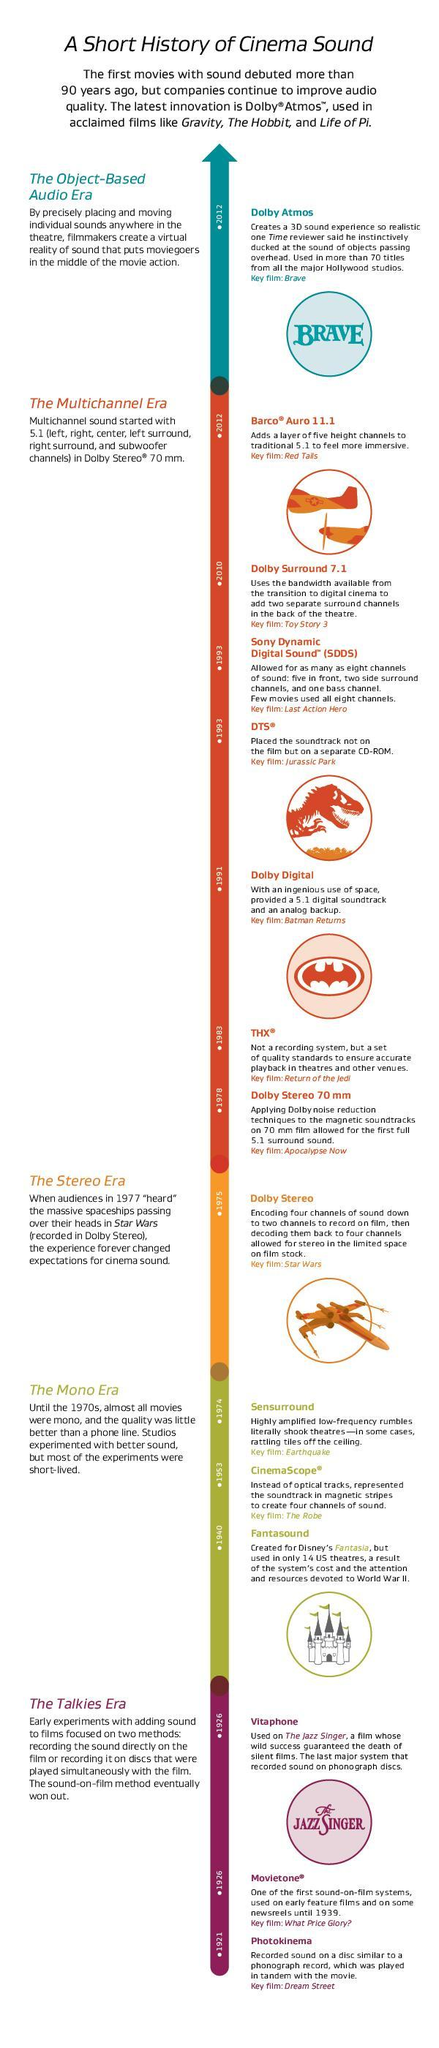Which era had the most number of audio systems?
Answer the question with a short phrase. The Multichannel Era Which sound system was so highly amplified that it shook of tiles from the ceiling? Sensurround In which year was the 'Dream Street' released using Photokinema? 1921 Which audio system is used today in films - Dolby Atmos, Vitaphone or Photokinema? Dolby Atmos What was the period between 1921 and 1926 called? The Talkies era In which Era, were sounds recorded separately on discs and played simultaneously with the film? The Talkies era Which audio system was used for the film, Star Wars? Dolby stereo How many different audio systems were used, in the Mono Era? 3 Which was the audio system used for the film, The Jazz Singer? Vitaphone Which image is used to represent the movie Jurassic park - bat, castle, dinosaur or aeroplane? Dinosaur Which sound system provided a 5.1 digital sound track and an analogue backup? Dolby digital Which sound system gives a 3D sound experience? Dolby Atmos Which audio era came before the Stereo Era? The Mono era How many audio eras are represented here? 5 In which year was the movie 'Apocalypse Now' released with Dolby stereo 70mm sound system? 1978 Which sound system was used for the movie Jurassic park? DTS Which audio system came first Dolby stereo or Dolby digital? Dolby stereo What is the colour used to represent the Talkies era- green, purple, red or orange? Purple Which audio system came first DTS or SDDS? DTS Which audio system was used first,  Fantasound or Movietone? Movietone Which audio system was used for Disney's Fantasia? Fantasound 